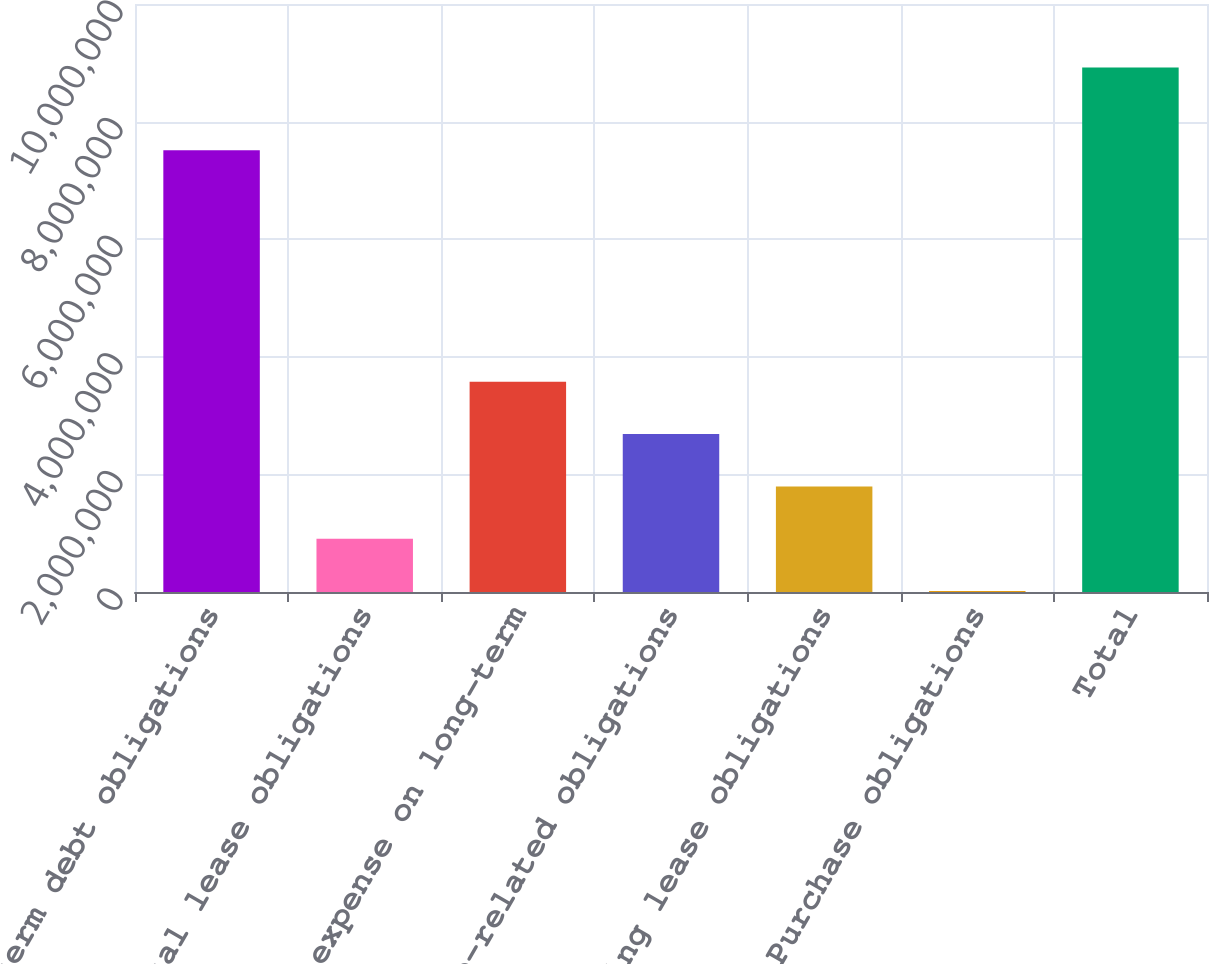Convert chart to OTSL. <chart><loc_0><loc_0><loc_500><loc_500><bar_chart><fcel>Long-term debt obligations<fcel>Capital lease obligations<fcel>Interest expense on long-term<fcel>Satellite-related obligations<fcel>Operating lease obligations<fcel>Purchase obligations<fcel>Total<nl><fcel>7.51476e+06<fcel>905235<fcel>3.57624e+06<fcel>2.6859e+06<fcel>1.79557e+06<fcel>14900<fcel>8.91825e+06<nl></chart> 